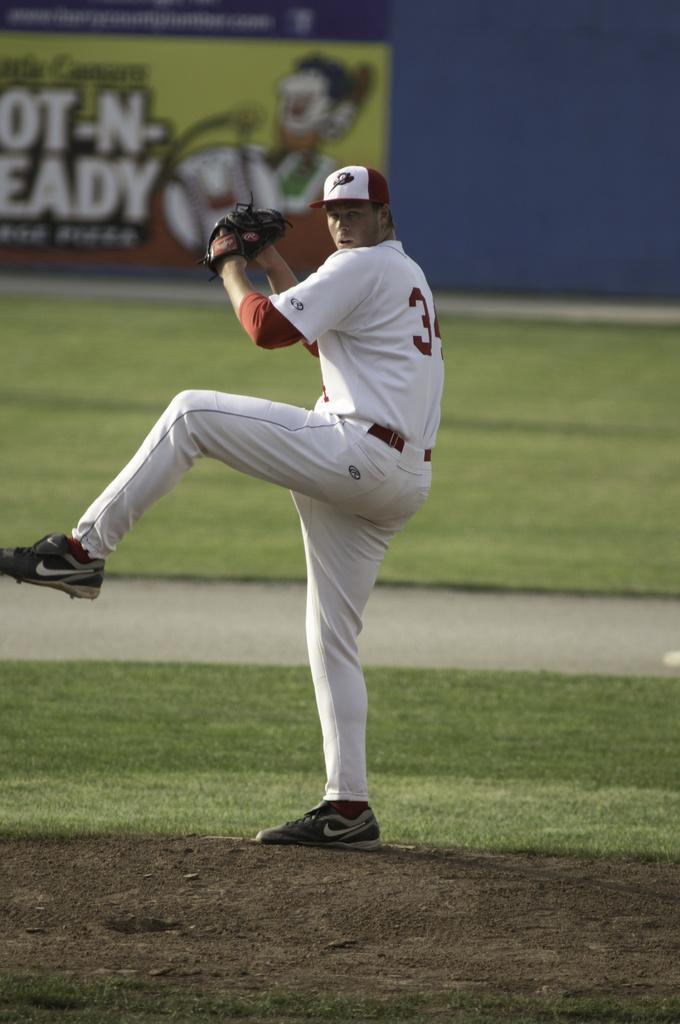What is the first number of that team member's number?
Provide a succinct answer. 3. 